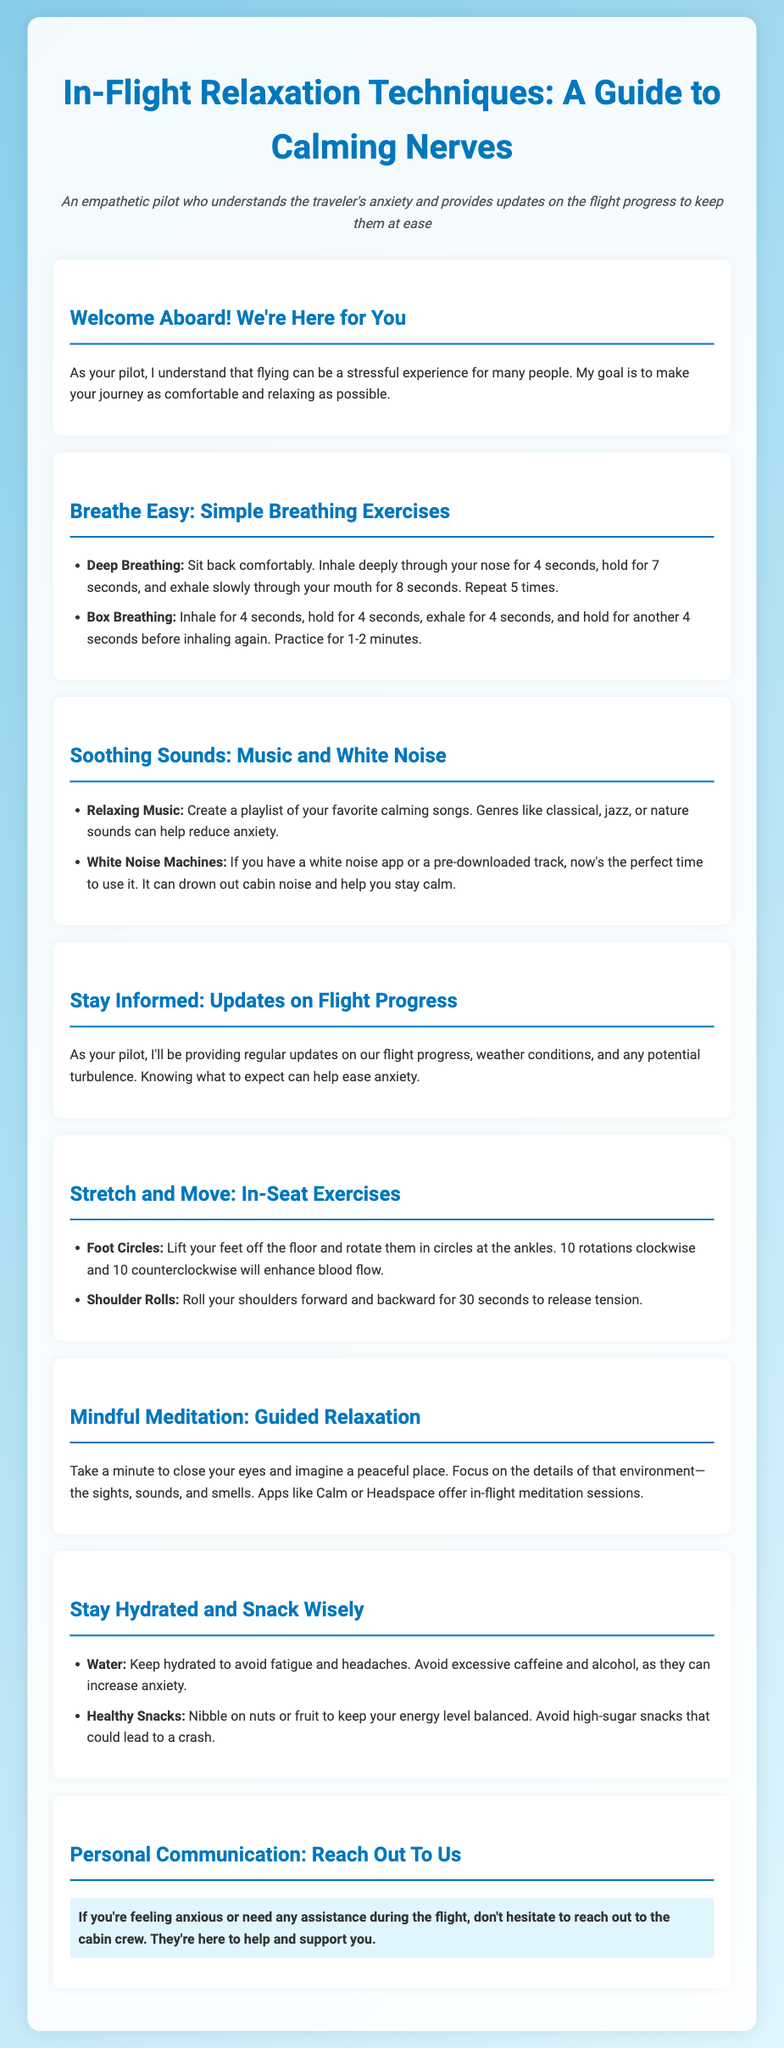What are the two breathing techniques mentioned? The document lists "Deep Breathing" and "Box Breathing" as the two breathing techniques.
Answer: Deep Breathing, Box Breathing What type of music is suggested for relaxation? The document suggests relaxing music genres such as classical, jazz, or nature sounds for calming.
Answer: Classical, jazz, or nature sounds How long should you practice box breathing? The document states that you should practice box breathing for 1-2 minutes.
Answer: 1-2 minutes What should you avoid to maintain hydration? The document advises avoiding excessive caffeine and alcohol to stay hydrated.
Answer: Excessive caffeine and alcohol What exercise is recommended to enhance blood flow? The document recommends "Foot Circles" as an exercise to enhance blood flow.
Answer: Foot Circles Who should you reach out to if you feel anxious? The document highlights that you should reach out to the cabin crew if you're feeling anxious.
Answer: Cabin crew 